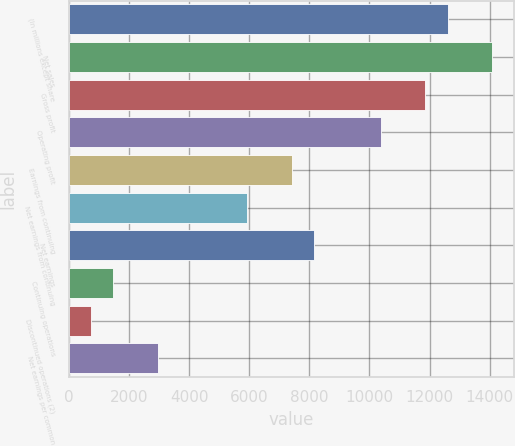Convert chart. <chart><loc_0><loc_0><loc_500><loc_500><bar_chart><fcel>(In millions except share<fcel>Net sales<fcel>Gross profit<fcel>Operating profit<fcel>Earnings from continuing<fcel>Net earnings from continuing<fcel>Net earnings<fcel>Continuing operations<fcel>Discontinued operations (2)<fcel>Net earnings per common<nl><fcel>12605.9<fcel>14088.9<fcel>11864.5<fcel>10381.5<fcel>7415.51<fcel>5932.53<fcel>8157<fcel>1483.59<fcel>742.1<fcel>2966.57<nl></chart> 